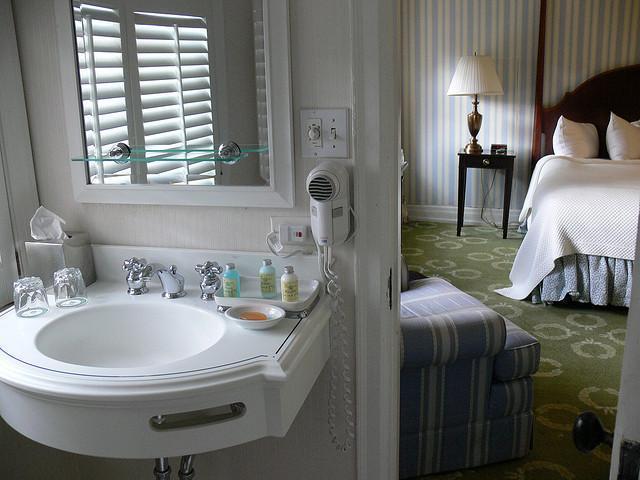What is the corded device called that's on the wall?
Choose the correct response and explain in the format: 'Answer: answer
Rationale: rationale.'
Options: Hair dryer, mixer, tv, wall phone. Answer: hair dryer.
Rationale: Hair dryers often are stored on hotel room walls and have curly cords. What is on the bed?
Select the accurate answer and provide justification: `Answer: choice
Rationale: srationale.`
Options: Dogs, pillows, old man, cats. Answer: pillows.
Rationale: These are fluffy stuffed fabric for your head 